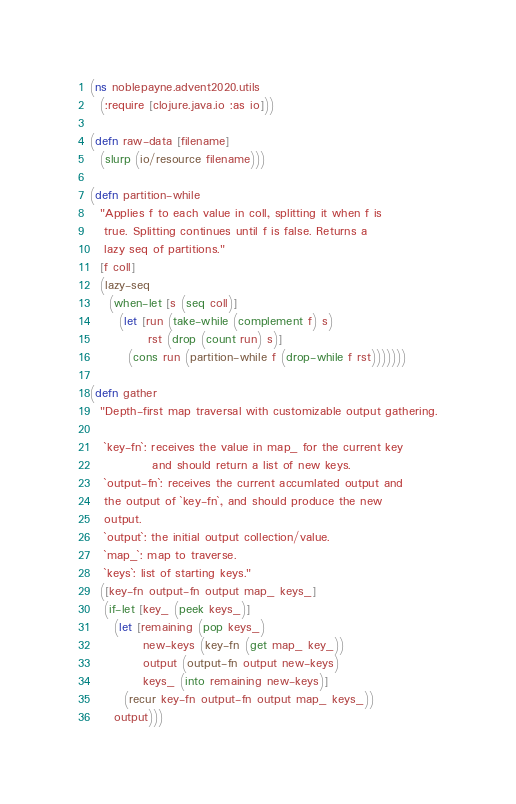<code> <loc_0><loc_0><loc_500><loc_500><_Clojure_>(ns noblepayne.advent2020.utils
  (:require [clojure.java.io :as io]))

(defn raw-data [filename]
  (slurp (io/resource filename)))

(defn partition-while
  "Applies f to each value in coll, splitting it when f is 
   true. Splitting continues until f is false. Returns a
   lazy seq of partitions."
  [f coll]
  (lazy-seq
    (when-let [s (seq coll)]
      (let [run (take-while (complement f) s)
            rst (drop (count run) s)]
        (cons run (partition-while f (drop-while f rst)))))))

(defn gather
  "Depth-first map traversal with customizable output gathering.

   `key-fn`: receives the value in map_ for the current key
             and should return a list of new keys.
   `output-fn`: receives the current accumlated output and
   the output of `key-fn`, and should produce the new
   output.
   `output`: the initial output collection/value.
   `map_`: map to traverse.
   `keys`: list of starting keys."
  ([key-fn output-fn output map_ keys_]
   (if-let [key_ (peek keys_)]
     (let [remaining (pop keys_)
           new-keys (key-fn (get map_ key_))
           output (output-fn output new-keys)
           keys_ (into remaining new-keys)]
       (recur key-fn output-fn output map_ keys_))
     output)))
</code> 